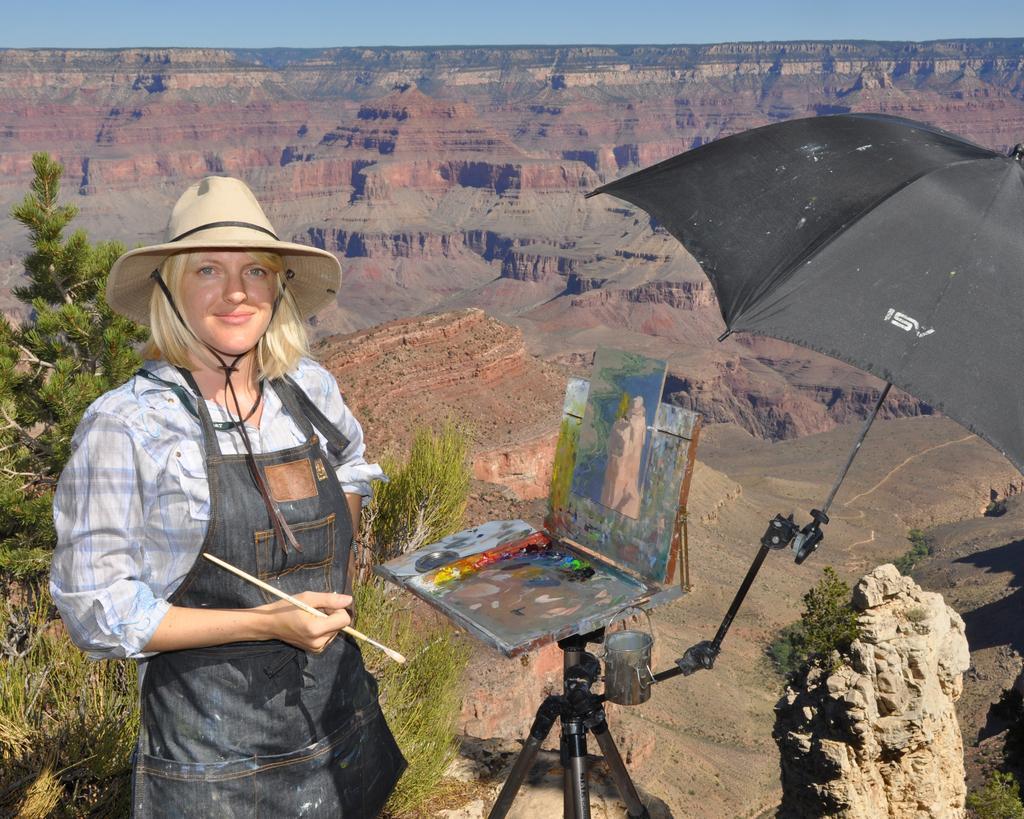Describe this image in one or two sentences. In the foreground I can see a woman is holding a brush in hand is standing in front of a stand on which a painting paper is there and an umbrella. In the background I can see trees, grass and mountains. At the top I can see the sky. This image is taken may be during a day. 